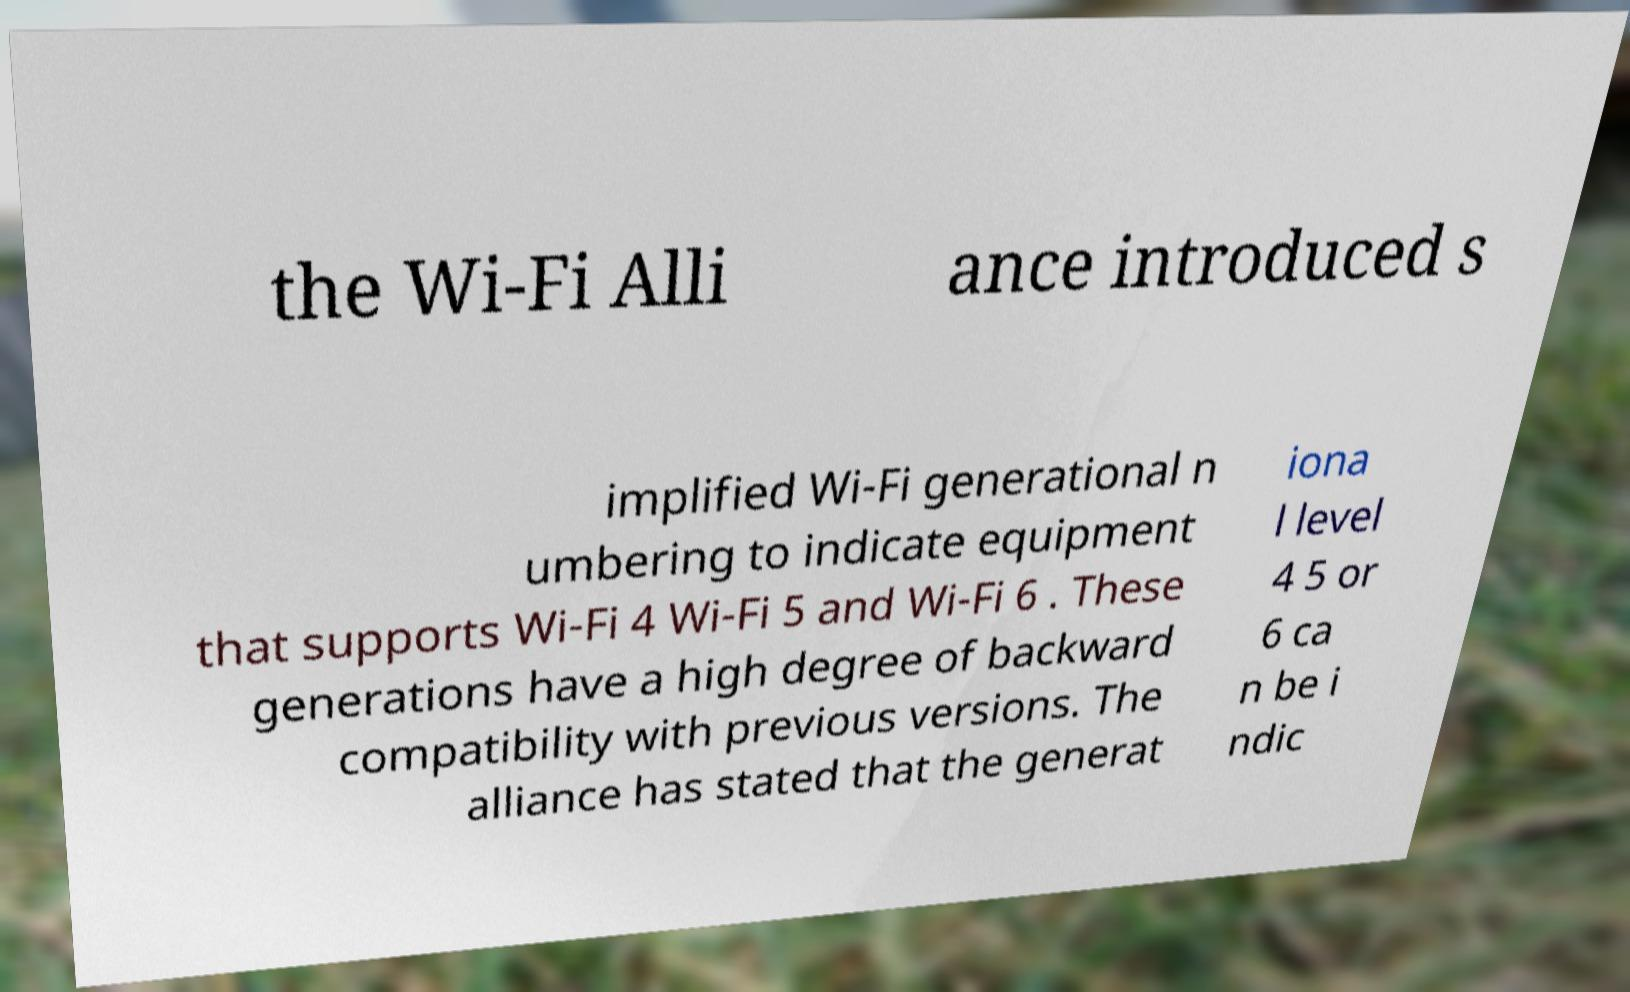What messages or text are displayed in this image? I need them in a readable, typed format. the Wi-Fi Alli ance introduced s implified Wi-Fi generational n umbering to indicate equipment that supports Wi-Fi 4 Wi-Fi 5 and Wi-Fi 6 . These generations have a high degree of backward compatibility with previous versions. The alliance has stated that the generat iona l level 4 5 or 6 ca n be i ndic 